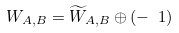Convert formula to latex. <formula><loc_0><loc_0><loc_500><loc_500>W _ { A , B } = \widetilde { W } _ { A , B } \oplus ( - \ 1 )</formula> 